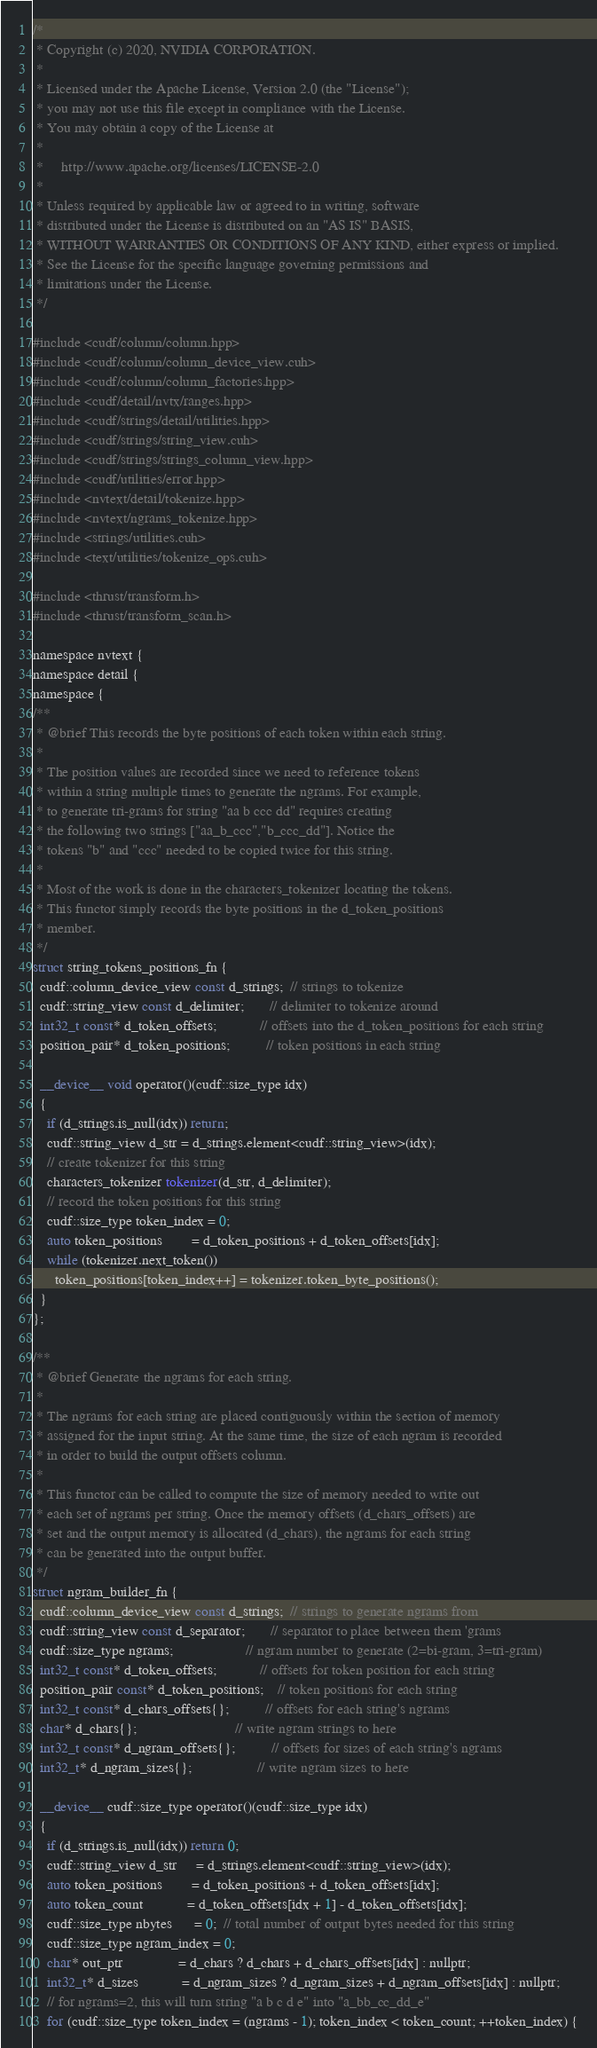<code> <loc_0><loc_0><loc_500><loc_500><_Cuda_>/*
 * Copyright (c) 2020, NVIDIA CORPORATION.
 *
 * Licensed under the Apache License, Version 2.0 (the "License");
 * you may not use this file except in compliance with the License.
 * You may obtain a copy of the License at
 *
 *     http://www.apache.org/licenses/LICENSE-2.0
 *
 * Unless required by applicable law or agreed to in writing, software
 * distributed under the License is distributed on an "AS IS" BASIS,
 * WITHOUT WARRANTIES OR CONDITIONS OF ANY KIND, either express or implied.
 * See the License for the specific language governing permissions and
 * limitations under the License.
 */

#include <cudf/column/column.hpp>
#include <cudf/column/column_device_view.cuh>
#include <cudf/column/column_factories.hpp>
#include <cudf/detail/nvtx/ranges.hpp>
#include <cudf/strings/detail/utilities.hpp>
#include <cudf/strings/string_view.cuh>
#include <cudf/strings/strings_column_view.hpp>
#include <cudf/utilities/error.hpp>
#include <nvtext/detail/tokenize.hpp>
#include <nvtext/ngrams_tokenize.hpp>
#include <strings/utilities.cuh>
#include <text/utilities/tokenize_ops.cuh>

#include <thrust/transform.h>
#include <thrust/transform_scan.h>

namespace nvtext {
namespace detail {
namespace {
/**
 * @brief This records the byte positions of each token within each string.
 *
 * The position values are recorded since we need to reference tokens
 * within a string multiple times to generate the ngrams. For example,
 * to generate tri-grams for string "aa b ccc dd" requires creating
 * the following two strings ["aa_b_ccc","b_ccc_dd"]. Notice the
 * tokens "b" and "ccc" needed to be copied twice for this string.
 *
 * Most of the work is done in the characters_tokenizer locating the tokens.
 * This functor simply records the byte positions in the d_token_positions
 * member.
 */
struct string_tokens_positions_fn {
  cudf::column_device_view const d_strings;  // strings to tokenize
  cudf::string_view const d_delimiter;       // delimiter to tokenize around
  int32_t const* d_token_offsets;            // offsets into the d_token_positions for each string
  position_pair* d_token_positions;          // token positions in each string

  __device__ void operator()(cudf::size_type idx)
  {
    if (d_strings.is_null(idx)) return;
    cudf::string_view d_str = d_strings.element<cudf::string_view>(idx);
    // create tokenizer for this string
    characters_tokenizer tokenizer(d_str, d_delimiter);
    // record the token positions for this string
    cudf::size_type token_index = 0;
    auto token_positions        = d_token_positions + d_token_offsets[idx];
    while (tokenizer.next_token())
      token_positions[token_index++] = tokenizer.token_byte_positions();
  }
};

/**
 * @brief Generate the ngrams for each string.
 *
 * The ngrams for each string are placed contiguously within the section of memory
 * assigned for the input string. At the same time, the size of each ngram is recorded
 * in order to build the output offsets column.
 *
 * This functor can be called to compute the size of memory needed to write out
 * each set of ngrams per string. Once the memory offsets (d_chars_offsets) are
 * set and the output memory is allocated (d_chars), the ngrams for each string
 * can be generated into the output buffer.
 */
struct ngram_builder_fn {
  cudf::column_device_view const d_strings;  // strings to generate ngrams from
  cudf::string_view const d_separator;       // separator to place between them 'grams
  cudf::size_type ngrams;                    // ngram number to generate (2=bi-gram, 3=tri-gram)
  int32_t const* d_token_offsets;            // offsets for token position for each string
  position_pair const* d_token_positions;    // token positions for each string
  int32_t const* d_chars_offsets{};          // offsets for each string's ngrams
  char* d_chars{};                           // write ngram strings to here
  int32_t const* d_ngram_offsets{};          // offsets for sizes of each string's ngrams
  int32_t* d_ngram_sizes{};                  // write ngram sizes to here

  __device__ cudf::size_type operator()(cudf::size_type idx)
  {
    if (d_strings.is_null(idx)) return 0;
    cudf::string_view d_str     = d_strings.element<cudf::string_view>(idx);
    auto token_positions        = d_token_positions + d_token_offsets[idx];
    auto token_count            = d_token_offsets[idx + 1] - d_token_offsets[idx];
    cudf::size_type nbytes      = 0;  // total number of output bytes needed for this string
    cudf::size_type ngram_index = 0;
    char* out_ptr               = d_chars ? d_chars + d_chars_offsets[idx] : nullptr;
    int32_t* d_sizes            = d_ngram_sizes ? d_ngram_sizes + d_ngram_offsets[idx] : nullptr;
    // for ngrams=2, this will turn string "a b c d e" into "a_bb_cc_dd_e"
    for (cudf::size_type token_index = (ngrams - 1); token_index < token_count; ++token_index) {</code> 